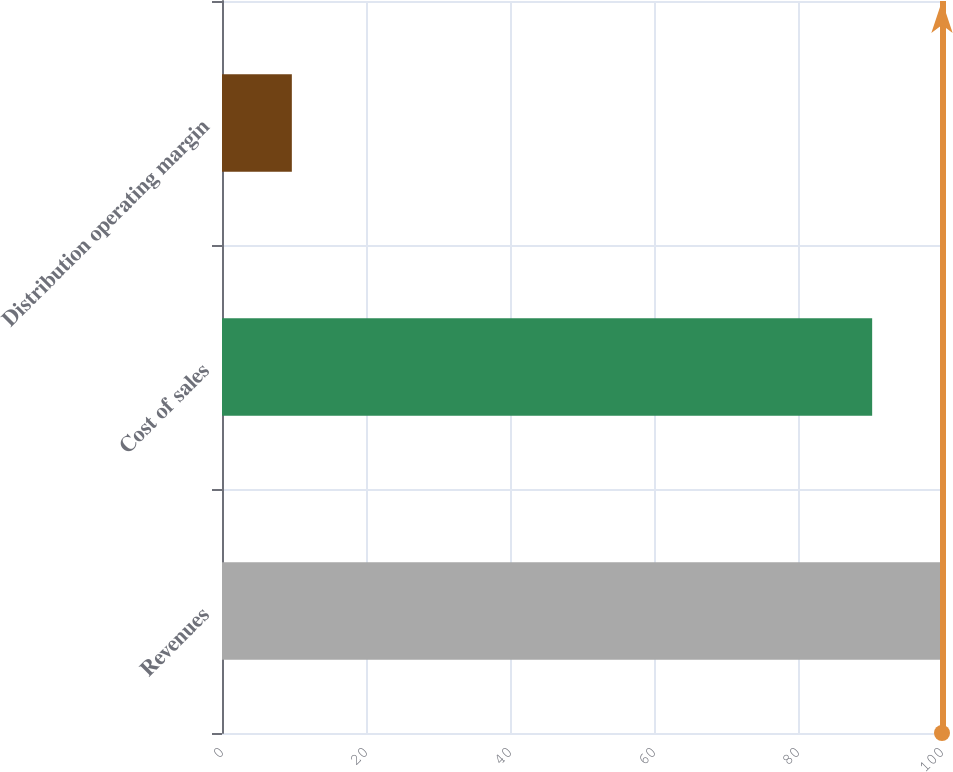<chart> <loc_0><loc_0><loc_500><loc_500><bar_chart><fcel>Revenues<fcel>Cost of sales<fcel>Distribution operating margin<nl><fcel>100<fcel>90.3<fcel>9.7<nl></chart> 